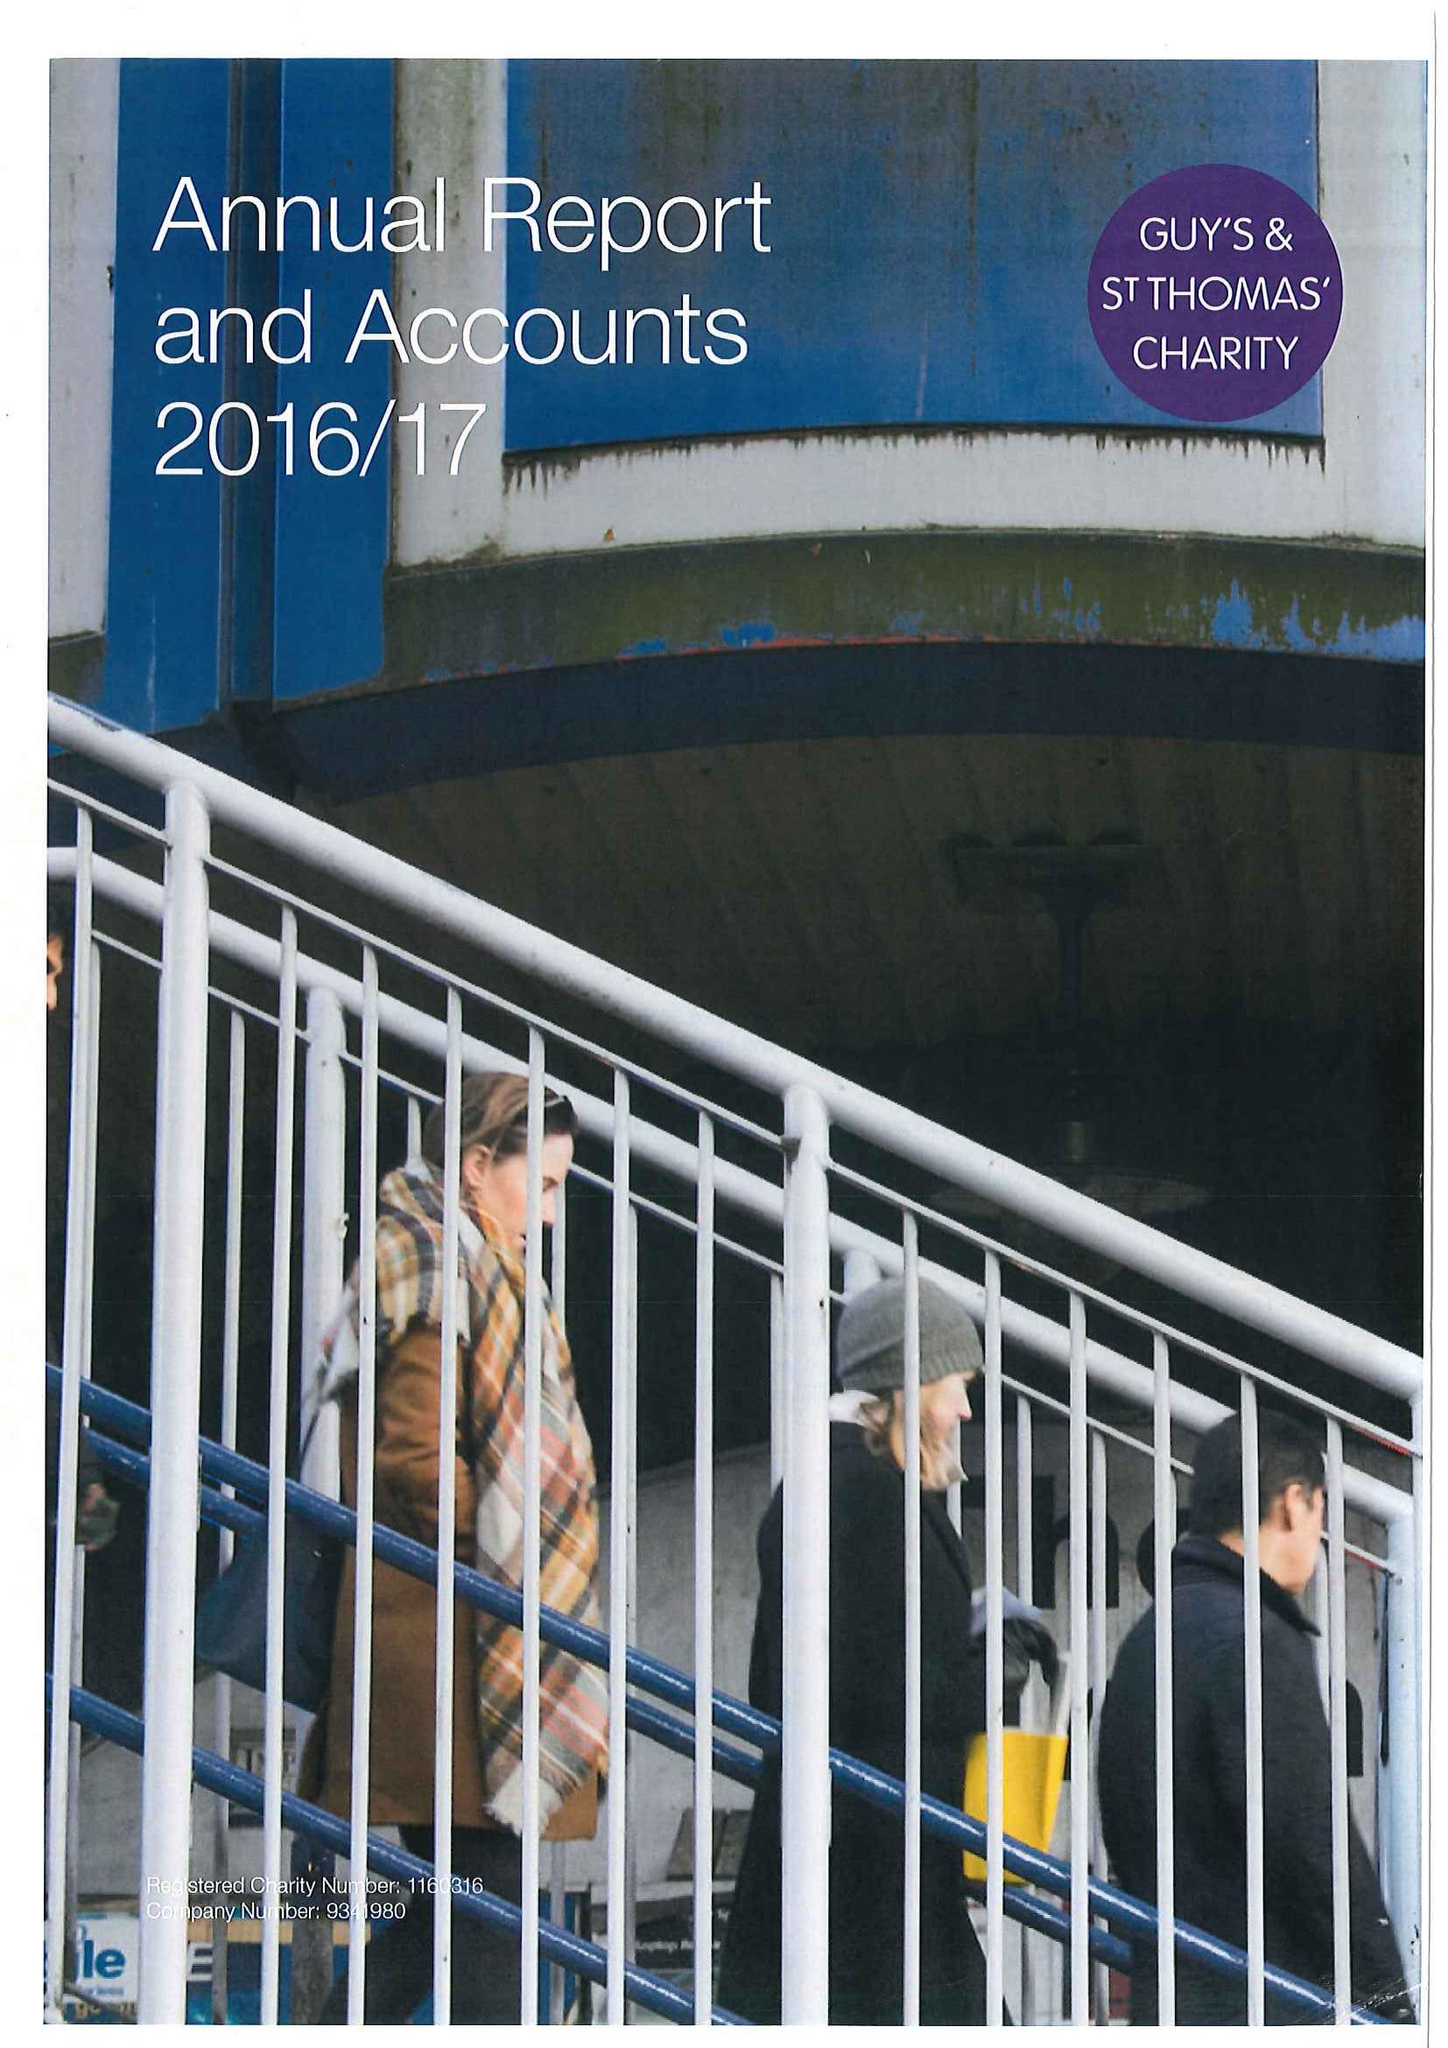What is the value for the address__street_line?
Answer the question using a single word or phrase. None 